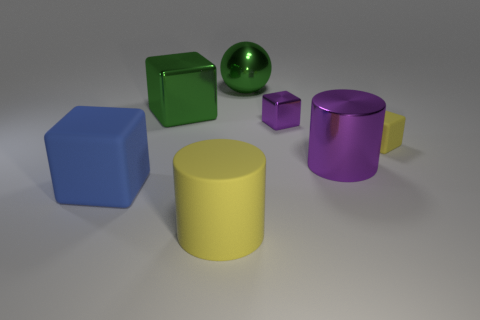What size is the green shiny thing that is the same shape as the tiny purple metal thing?
Offer a very short reply. Large. Is there another matte cube that has the same size as the green cube?
Your answer should be very brief. Yes. What is the material of the yellow thing right of the small block that is behind the yellow object that is on the right side of the big green ball?
Offer a terse response. Rubber. There is a small block that is on the left side of the tiny yellow rubber block; what number of purple cubes are right of it?
Make the answer very short. 0. There is a rubber object on the right side of the ball; is its size the same as the blue rubber block?
Provide a succinct answer. No. How many other blue things have the same shape as the large blue rubber thing?
Give a very brief answer. 0. What is the shape of the blue object?
Provide a short and direct response. Cube. Are there the same number of big green things that are in front of the large ball and blue cylinders?
Ensure brevity in your answer.  No. Is there anything else that is made of the same material as the yellow cylinder?
Make the answer very short. Yes. Do the tiny thing behind the tiny yellow matte thing and the big ball have the same material?
Your answer should be compact. Yes. 